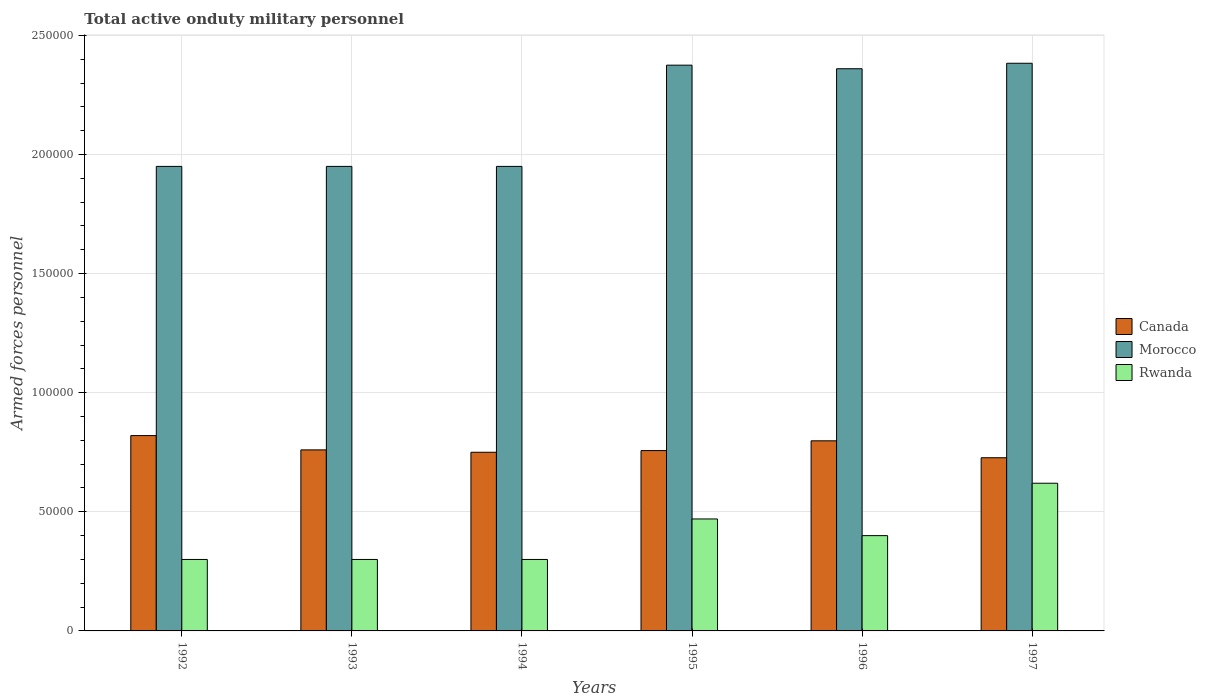How many different coloured bars are there?
Your answer should be very brief. 3. Are the number of bars on each tick of the X-axis equal?
Provide a succinct answer. Yes. How many bars are there on the 4th tick from the left?
Your answer should be compact. 3. In how many cases, is the number of bars for a given year not equal to the number of legend labels?
Keep it short and to the point. 0. What is the number of armed forces personnel in Morocco in 1996?
Your answer should be compact. 2.36e+05. Across all years, what is the maximum number of armed forces personnel in Morocco?
Give a very brief answer. 2.38e+05. Across all years, what is the minimum number of armed forces personnel in Rwanda?
Keep it short and to the point. 3.00e+04. What is the total number of armed forces personnel in Morocco in the graph?
Make the answer very short. 1.30e+06. What is the difference between the number of armed forces personnel in Rwanda in 1993 and that in 1996?
Your response must be concise. -10000. What is the difference between the number of armed forces personnel in Canada in 1997 and the number of armed forces personnel in Rwanda in 1995?
Offer a very short reply. 2.57e+04. What is the average number of armed forces personnel in Canada per year?
Your answer should be compact. 7.69e+04. In the year 1996, what is the difference between the number of armed forces personnel in Rwanda and number of armed forces personnel in Morocco?
Your answer should be very brief. -1.96e+05. What is the ratio of the number of armed forces personnel in Canada in 1993 to that in 1996?
Give a very brief answer. 0.95. Is the number of armed forces personnel in Morocco in 1995 less than that in 1997?
Provide a succinct answer. Yes. What is the difference between the highest and the second highest number of armed forces personnel in Morocco?
Give a very brief answer. 800. What is the difference between the highest and the lowest number of armed forces personnel in Canada?
Give a very brief answer. 9300. In how many years, is the number of armed forces personnel in Canada greater than the average number of armed forces personnel in Canada taken over all years?
Offer a very short reply. 2. Is the sum of the number of armed forces personnel in Canada in 1993 and 1996 greater than the maximum number of armed forces personnel in Rwanda across all years?
Your response must be concise. Yes. What does the 2nd bar from the left in 1996 represents?
Offer a very short reply. Morocco. What does the 1st bar from the right in 1994 represents?
Make the answer very short. Rwanda. Is it the case that in every year, the sum of the number of armed forces personnel in Rwanda and number of armed forces personnel in Canada is greater than the number of armed forces personnel in Morocco?
Keep it short and to the point. No. How many bars are there?
Ensure brevity in your answer.  18. Are all the bars in the graph horizontal?
Provide a short and direct response. No. How many years are there in the graph?
Give a very brief answer. 6. What is the difference between two consecutive major ticks on the Y-axis?
Offer a terse response. 5.00e+04. Does the graph contain grids?
Your answer should be compact. Yes. How many legend labels are there?
Provide a succinct answer. 3. What is the title of the graph?
Your answer should be compact. Total active onduty military personnel. Does "Ireland" appear as one of the legend labels in the graph?
Ensure brevity in your answer.  No. What is the label or title of the X-axis?
Your response must be concise. Years. What is the label or title of the Y-axis?
Provide a succinct answer. Armed forces personnel. What is the Armed forces personnel of Canada in 1992?
Your answer should be compact. 8.20e+04. What is the Armed forces personnel in Morocco in 1992?
Make the answer very short. 1.95e+05. What is the Armed forces personnel of Rwanda in 1992?
Provide a short and direct response. 3.00e+04. What is the Armed forces personnel in Canada in 1993?
Provide a succinct answer. 7.60e+04. What is the Armed forces personnel in Morocco in 1993?
Offer a very short reply. 1.95e+05. What is the Armed forces personnel in Rwanda in 1993?
Ensure brevity in your answer.  3.00e+04. What is the Armed forces personnel of Canada in 1994?
Offer a very short reply. 7.50e+04. What is the Armed forces personnel of Morocco in 1994?
Provide a succinct answer. 1.95e+05. What is the Armed forces personnel in Canada in 1995?
Give a very brief answer. 7.57e+04. What is the Armed forces personnel in Morocco in 1995?
Provide a short and direct response. 2.38e+05. What is the Armed forces personnel in Rwanda in 1995?
Make the answer very short. 4.70e+04. What is the Armed forces personnel in Canada in 1996?
Your response must be concise. 7.98e+04. What is the Armed forces personnel of Morocco in 1996?
Give a very brief answer. 2.36e+05. What is the Armed forces personnel in Canada in 1997?
Provide a short and direct response. 7.27e+04. What is the Armed forces personnel of Morocco in 1997?
Your answer should be compact. 2.38e+05. What is the Armed forces personnel in Rwanda in 1997?
Make the answer very short. 6.20e+04. Across all years, what is the maximum Armed forces personnel in Canada?
Your answer should be compact. 8.20e+04. Across all years, what is the maximum Armed forces personnel in Morocco?
Make the answer very short. 2.38e+05. Across all years, what is the maximum Armed forces personnel of Rwanda?
Ensure brevity in your answer.  6.20e+04. Across all years, what is the minimum Armed forces personnel in Canada?
Offer a very short reply. 7.27e+04. Across all years, what is the minimum Armed forces personnel in Morocco?
Keep it short and to the point. 1.95e+05. What is the total Armed forces personnel of Canada in the graph?
Give a very brief answer. 4.61e+05. What is the total Armed forces personnel of Morocco in the graph?
Your answer should be very brief. 1.30e+06. What is the total Armed forces personnel in Rwanda in the graph?
Your answer should be very brief. 2.39e+05. What is the difference between the Armed forces personnel in Canada in 1992 and that in 1993?
Your answer should be compact. 6000. What is the difference between the Armed forces personnel of Morocco in 1992 and that in 1993?
Make the answer very short. 0. What is the difference between the Armed forces personnel of Canada in 1992 and that in 1994?
Your answer should be very brief. 7000. What is the difference between the Armed forces personnel of Canada in 1992 and that in 1995?
Make the answer very short. 6300. What is the difference between the Armed forces personnel in Morocco in 1992 and that in 1995?
Make the answer very short. -4.25e+04. What is the difference between the Armed forces personnel of Rwanda in 1992 and that in 1995?
Your answer should be compact. -1.70e+04. What is the difference between the Armed forces personnel of Canada in 1992 and that in 1996?
Offer a terse response. 2200. What is the difference between the Armed forces personnel in Morocco in 1992 and that in 1996?
Offer a very short reply. -4.10e+04. What is the difference between the Armed forces personnel in Rwanda in 1992 and that in 1996?
Offer a very short reply. -10000. What is the difference between the Armed forces personnel of Canada in 1992 and that in 1997?
Offer a terse response. 9300. What is the difference between the Armed forces personnel of Morocco in 1992 and that in 1997?
Your response must be concise. -4.33e+04. What is the difference between the Armed forces personnel of Rwanda in 1992 and that in 1997?
Provide a succinct answer. -3.20e+04. What is the difference between the Armed forces personnel of Canada in 1993 and that in 1994?
Your response must be concise. 1000. What is the difference between the Armed forces personnel of Morocco in 1993 and that in 1994?
Provide a succinct answer. 0. What is the difference between the Armed forces personnel in Canada in 1993 and that in 1995?
Offer a terse response. 300. What is the difference between the Armed forces personnel of Morocco in 1993 and that in 1995?
Offer a terse response. -4.25e+04. What is the difference between the Armed forces personnel in Rwanda in 1993 and that in 1995?
Offer a terse response. -1.70e+04. What is the difference between the Armed forces personnel in Canada in 1993 and that in 1996?
Keep it short and to the point. -3800. What is the difference between the Armed forces personnel in Morocco in 1993 and that in 1996?
Offer a very short reply. -4.10e+04. What is the difference between the Armed forces personnel in Rwanda in 1993 and that in 1996?
Make the answer very short. -10000. What is the difference between the Armed forces personnel in Canada in 1993 and that in 1997?
Make the answer very short. 3300. What is the difference between the Armed forces personnel of Morocco in 1993 and that in 1997?
Make the answer very short. -4.33e+04. What is the difference between the Armed forces personnel in Rwanda in 1993 and that in 1997?
Your answer should be very brief. -3.20e+04. What is the difference between the Armed forces personnel in Canada in 1994 and that in 1995?
Ensure brevity in your answer.  -700. What is the difference between the Armed forces personnel of Morocco in 1994 and that in 1995?
Give a very brief answer. -4.25e+04. What is the difference between the Armed forces personnel in Rwanda in 1994 and that in 1995?
Offer a very short reply. -1.70e+04. What is the difference between the Armed forces personnel in Canada in 1994 and that in 1996?
Make the answer very short. -4800. What is the difference between the Armed forces personnel of Morocco in 1994 and that in 1996?
Provide a short and direct response. -4.10e+04. What is the difference between the Armed forces personnel in Canada in 1994 and that in 1997?
Your answer should be compact. 2300. What is the difference between the Armed forces personnel in Morocco in 1994 and that in 1997?
Offer a very short reply. -4.33e+04. What is the difference between the Armed forces personnel of Rwanda in 1994 and that in 1997?
Your answer should be very brief. -3.20e+04. What is the difference between the Armed forces personnel in Canada in 1995 and that in 1996?
Give a very brief answer. -4100. What is the difference between the Armed forces personnel of Morocco in 1995 and that in 1996?
Your answer should be very brief. 1500. What is the difference between the Armed forces personnel of Rwanda in 1995 and that in 1996?
Provide a succinct answer. 7000. What is the difference between the Armed forces personnel in Canada in 1995 and that in 1997?
Offer a terse response. 3000. What is the difference between the Armed forces personnel in Morocco in 1995 and that in 1997?
Offer a very short reply. -800. What is the difference between the Armed forces personnel of Rwanda in 1995 and that in 1997?
Your answer should be very brief. -1.50e+04. What is the difference between the Armed forces personnel in Canada in 1996 and that in 1997?
Make the answer very short. 7100. What is the difference between the Armed forces personnel of Morocco in 1996 and that in 1997?
Provide a succinct answer. -2300. What is the difference between the Armed forces personnel in Rwanda in 1996 and that in 1997?
Provide a succinct answer. -2.20e+04. What is the difference between the Armed forces personnel of Canada in 1992 and the Armed forces personnel of Morocco in 1993?
Make the answer very short. -1.13e+05. What is the difference between the Armed forces personnel of Canada in 1992 and the Armed forces personnel of Rwanda in 1993?
Your answer should be very brief. 5.20e+04. What is the difference between the Armed forces personnel of Morocco in 1992 and the Armed forces personnel of Rwanda in 1993?
Give a very brief answer. 1.65e+05. What is the difference between the Armed forces personnel of Canada in 1992 and the Armed forces personnel of Morocco in 1994?
Offer a terse response. -1.13e+05. What is the difference between the Armed forces personnel in Canada in 1992 and the Armed forces personnel in Rwanda in 1994?
Provide a short and direct response. 5.20e+04. What is the difference between the Armed forces personnel of Morocco in 1992 and the Armed forces personnel of Rwanda in 1994?
Your answer should be very brief. 1.65e+05. What is the difference between the Armed forces personnel in Canada in 1992 and the Armed forces personnel in Morocco in 1995?
Provide a short and direct response. -1.56e+05. What is the difference between the Armed forces personnel of Canada in 1992 and the Armed forces personnel of Rwanda in 1995?
Offer a very short reply. 3.50e+04. What is the difference between the Armed forces personnel in Morocco in 1992 and the Armed forces personnel in Rwanda in 1995?
Your response must be concise. 1.48e+05. What is the difference between the Armed forces personnel of Canada in 1992 and the Armed forces personnel of Morocco in 1996?
Your answer should be compact. -1.54e+05. What is the difference between the Armed forces personnel in Canada in 1992 and the Armed forces personnel in Rwanda in 1996?
Provide a succinct answer. 4.20e+04. What is the difference between the Armed forces personnel in Morocco in 1992 and the Armed forces personnel in Rwanda in 1996?
Offer a terse response. 1.55e+05. What is the difference between the Armed forces personnel of Canada in 1992 and the Armed forces personnel of Morocco in 1997?
Your answer should be very brief. -1.56e+05. What is the difference between the Armed forces personnel in Morocco in 1992 and the Armed forces personnel in Rwanda in 1997?
Your answer should be very brief. 1.33e+05. What is the difference between the Armed forces personnel in Canada in 1993 and the Armed forces personnel in Morocco in 1994?
Your response must be concise. -1.19e+05. What is the difference between the Armed forces personnel of Canada in 1993 and the Armed forces personnel of Rwanda in 1994?
Your response must be concise. 4.60e+04. What is the difference between the Armed forces personnel in Morocco in 1993 and the Armed forces personnel in Rwanda in 1994?
Keep it short and to the point. 1.65e+05. What is the difference between the Armed forces personnel of Canada in 1993 and the Armed forces personnel of Morocco in 1995?
Your answer should be compact. -1.62e+05. What is the difference between the Armed forces personnel of Canada in 1993 and the Armed forces personnel of Rwanda in 1995?
Your answer should be compact. 2.90e+04. What is the difference between the Armed forces personnel in Morocco in 1993 and the Armed forces personnel in Rwanda in 1995?
Provide a succinct answer. 1.48e+05. What is the difference between the Armed forces personnel of Canada in 1993 and the Armed forces personnel of Morocco in 1996?
Keep it short and to the point. -1.60e+05. What is the difference between the Armed forces personnel of Canada in 1993 and the Armed forces personnel of Rwanda in 1996?
Keep it short and to the point. 3.60e+04. What is the difference between the Armed forces personnel of Morocco in 1993 and the Armed forces personnel of Rwanda in 1996?
Your answer should be compact. 1.55e+05. What is the difference between the Armed forces personnel in Canada in 1993 and the Armed forces personnel in Morocco in 1997?
Your response must be concise. -1.62e+05. What is the difference between the Armed forces personnel in Canada in 1993 and the Armed forces personnel in Rwanda in 1997?
Your answer should be very brief. 1.40e+04. What is the difference between the Armed forces personnel in Morocco in 1993 and the Armed forces personnel in Rwanda in 1997?
Keep it short and to the point. 1.33e+05. What is the difference between the Armed forces personnel of Canada in 1994 and the Armed forces personnel of Morocco in 1995?
Make the answer very short. -1.62e+05. What is the difference between the Armed forces personnel of Canada in 1994 and the Armed forces personnel of Rwanda in 1995?
Your answer should be very brief. 2.80e+04. What is the difference between the Armed forces personnel in Morocco in 1994 and the Armed forces personnel in Rwanda in 1995?
Ensure brevity in your answer.  1.48e+05. What is the difference between the Armed forces personnel in Canada in 1994 and the Armed forces personnel in Morocco in 1996?
Your answer should be very brief. -1.61e+05. What is the difference between the Armed forces personnel of Canada in 1994 and the Armed forces personnel of Rwanda in 1996?
Make the answer very short. 3.50e+04. What is the difference between the Armed forces personnel in Morocco in 1994 and the Armed forces personnel in Rwanda in 1996?
Provide a short and direct response. 1.55e+05. What is the difference between the Armed forces personnel of Canada in 1994 and the Armed forces personnel of Morocco in 1997?
Keep it short and to the point. -1.63e+05. What is the difference between the Armed forces personnel of Canada in 1994 and the Armed forces personnel of Rwanda in 1997?
Keep it short and to the point. 1.30e+04. What is the difference between the Armed forces personnel of Morocco in 1994 and the Armed forces personnel of Rwanda in 1997?
Provide a succinct answer. 1.33e+05. What is the difference between the Armed forces personnel of Canada in 1995 and the Armed forces personnel of Morocco in 1996?
Ensure brevity in your answer.  -1.60e+05. What is the difference between the Armed forces personnel in Canada in 1995 and the Armed forces personnel in Rwanda in 1996?
Provide a succinct answer. 3.57e+04. What is the difference between the Armed forces personnel in Morocco in 1995 and the Armed forces personnel in Rwanda in 1996?
Provide a short and direct response. 1.98e+05. What is the difference between the Armed forces personnel in Canada in 1995 and the Armed forces personnel in Morocco in 1997?
Offer a very short reply. -1.63e+05. What is the difference between the Armed forces personnel in Canada in 1995 and the Armed forces personnel in Rwanda in 1997?
Provide a succinct answer. 1.37e+04. What is the difference between the Armed forces personnel of Morocco in 1995 and the Armed forces personnel of Rwanda in 1997?
Provide a succinct answer. 1.76e+05. What is the difference between the Armed forces personnel in Canada in 1996 and the Armed forces personnel in Morocco in 1997?
Offer a very short reply. -1.58e+05. What is the difference between the Armed forces personnel of Canada in 1996 and the Armed forces personnel of Rwanda in 1997?
Your response must be concise. 1.78e+04. What is the difference between the Armed forces personnel in Morocco in 1996 and the Armed forces personnel in Rwanda in 1997?
Ensure brevity in your answer.  1.74e+05. What is the average Armed forces personnel of Canada per year?
Offer a terse response. 7.69e+04. What is the average Armed forces personnel of Morocco per year?
Ensure brevity in your answer.  2.16e+05. What is the average Armed forces personnel in Rwanda per year?
Your response must be concise. 3.98e+04. In the year 1992, what is the difference between the Armed forces personnel of Canada and Armed forces personnel of Morocco?
Make the answer very short. -1.13e+05. In the year 1992, what is the difference between the Armed forces personnel of Canada and Armed forces personnel of Rwanda?
Your response must be concise. 5.20e+04. In the year 1992, what is the difference between the Armed forces personnel in Morocco and Armed forces personnel in Rwanda?
Your answer should be very brief. 1.65e+05. In the year 1993, what is the difference between the Armed forces personnel in Canada and Armed forces personnel in Morocco?
Keep it short and to the point. -1.19e+05. In the year 1993, what is the difference between the Armed forces personnel in Canada and Armed forces personnel in Rwanda?
Provide a succinct answer. 4.60e+04. In the year 1993, what is the difference between the Armed forces personnel of Morocco and Armed forces personnel of Rwanda?
Offer a very short reply. 1.65e+05. In the year 1994, what is the difference between the Armed forces personnel in Canada and Armed forces personnel in Rwanda?
Provide a succinct answer. 4.50e+04. In the year 1994, what is the difference between the Armed forces personnel of Morocco and Armed forces personnel of Rwanda?
Your answer should be compact. 1.65e+05. In the year 1995, what is the difference between the Armed forces personnel of Canada and Armed forces personnel of Morocco?
Keep it short and to the point. -1.62e+05. In the year 1995, what is the difference between the Armed forces personnel in Canada and Armed forces personnel in Rwanda?
Your answer should be very brief. 2.87e+04. In the year 1995, what is the difference between the Armed forces personnel of Morocco and Armed forces personnel of Rwanda?
Keep it short and to the point. 1.90e+05. In the year 1996, what is the difference between the Armed forces personnel of Canada and Armed forces personnel of Morocco?
Your answer should be very brief. -1.56e+05. In the year 1996, what is the difference between the Armed forces personnel in Canada and Armed forces personnel in Rwanda?
Provide a short and direct response. 3.98e+04. In the year 1996, what is the difference between the Armed forces personnel in Morocco and Armed forces personnel in Rwanda?
Provide a short and direct response. 1.96e+05. In the year 1997, what is the difference between the Armed forces personnel of Canada and Armed forces personnel of Morocco?
Your answer should be compact. -1.66e+05. In the year 1997, what is the difference between the Armed forces personnel of Canada and Armed forces personnel of Rwanda?
Offer a terse response. 1.07e+04. In the year 1997, what is the difference between the Armed forces personnel of Morocco and Armed forces personnel of Rwanda?
Your answer should be compact. 1.76e+05. What is the ratio of the Armed forces personnel of Canada in 1992 to that in 1993?
Offer a terse response. 1.08. What is the ratio of the Armed forces personnel in Morocco in 1992 to that in 1993?
Ensure brevity in your answer.  1. What is the ratio of the Armed forces personnel in Rwanda in 1992 to that in 1993?
Provide a short and direct response. 1. What is the ratio of the Armed forces personnel of Canada in 1992 to that in 1994?
Ensure brevity in your answer.  1.09. What is the ratio of the Armed forces personnel of Canada in 1992 to that in 1995?
Ensure brevity in your answer.  1.08. What is the ratio of the Armed forces personnel of Morocco in 1992 to that in 1995?
Offer a very short reply. 0.82. What is the ratio of the Armed forces personnel in Rwanda in 1992 to that in 1995?
Ensure brevity in your answer.  0.64. What is the ratio of the Armed forces personnel of Canada in 1992 to that in 1996?
Ensure brevity in your answer.  1.03. What is the ratio of the Armed forces personnel of Morocco in 1992 to that in 1996?
Make the answer very short. 0.83. What is the ratio of the Armed forces personnel of Rwanda in 1992 to that in 1996?
Ensure brevity in your answer.  0.75. What is the ratio of the Armed forces personnel in Canada in 1992 to that in 1997?
Your response must be concise. 1.13. What is the ratio of the Armed forces personnel in Morocco in 1992 to that in 1997?
Provide a short and direct response. 0.82. What is the ratio of the Armed forces personnel of Rwanda in 1992 to that in 1997?
Offer a very short reply. 0.48. What is the ratio of the Armed forces personnel in Canada in 1993 to that in 1994?
Provide a short and direct response. 1.01. What is the ratio of the Armed forces personnel of Morocco in 1993 to that in 1994?
Provide a short and direct response. 1. What is the ratio of the Armed forces personnel of Morocco in 1993 to that in 1995?
Make the answer very short. 0.82. What is the ratio of the Armed forces personnel of Rwanda in 1993 to that in 1995?
Your answer should be compact. 0.64. What is the ratio of the Armed forces personnel in Morocco in 1993 to that in 1996?
Give a very brief answer. 0.83. What is the ratio of the Armed forces personnel of Rwanda in 1993 to that in 1996?
Ensure brevity in your answer.  0.75. What is the ratio of the Armed forces personnel in Canada in 1993 to that in 1997?
Give a very brief answer. 1.05. What is the ratio of the Armed forces personnel in Morocco in 1993 to that in 1997?
Provide a succinct answer. 0.82. What is the ratio of the Armed forces personnel in Rwanda in 1993 to that in 1997?
Offer a very short reply. 0.48. What is the ratio of the Armed forces personnel of Canada in 1994 to that in 1995?
Your response must be concise. 0.99. What is the ratio of the Armed forces personnel in Morocco in 1994 to that in 1995?
Keep it short and to the point. 0.82. What is the ratio of the Armed forces personnel of Rwanda in 1994 to that in 1995?
Offer a terse response. 0.64. What is the ratio of the Armed forces personnel of Canada in 1994 to that in 1996?
Keep it short and to the point. 0.94. What is the ratio of the Armed forces personnel in Morocco in 1994 to that in 1996?
Your answer should be very brief. 0.83. What is the ratio of the Armed forces personnel in Canada in 1994 to that in 1997?
Offer a terse response. 1.03. What is the ratio of the Armed forces personnel in Morocco in 1994 to that in 1997?
Make the answer very short. 0.82. What is the ratio of the Armed forces personnel of Rwanda in 1994 to that in 1997?
Make the answer very short. 0.48. What is the ratio of the Armed forces personnel of Canada in 1995 to that in 1996?
Your answer should be very brief. 0.95. What is the ratio of the Armed forces personnel of Morocco in 1995 to that in 1996?
Keep it short and to the point. 1.01. What is the ratio of the Armed forces personnel of Rwanda in 1995 to that in 1996?
Offer a very short reply. 1.18. What is the ratio of the Armed forces personnel in Canada in 1995 to that in 1997?
Offer a terse response. 1.04. What is the ratio of the Armed forces personnel in Morocco in 1995 to that in 1997?
Your answer should be very brief. 1. What is the ratio of the Armed forces personnel in Rwanda in 1995 to that in 1997?
Your response must be concise. 0.76. What is the ratio of the Armed forces personnel in Canada in 1996 to that in 1997?
Offer a very short reply. 1.1. What is the ratio of the Armed forces personnel in Morocco in 1996 to that in 1997?
Keep it short and to the point. 0.99. What is the ratio of the Armed forces personnel of Rwanda in 1996 to that in 1997?
Provide a short and direct response. 0.65. What is the difference between the highest and the second highest Armed forces personnel of Canada?
Provide a succinct answer. 2200. What is the difference between the highest and the second highest Armed forces personnel of Morocco?
Provide a succinct answer. 800. What is the difference between the highest and the second highest Armed forces personnel of Rwanda?
Provide a short and direct response. 1.50e+04. What is the difference between the highest and the lowest Armed forces personnel in Canada?
Offer a terse response. 9300. What is the difference between the highest and the lowest Armed forces personnel of Morocco?
Offer a terse response. 4.33e+04. What is the difference between the highest and the lowest Armed forces personnel in Rwanda?
Ensure brevity in your answer.  3.20e+04. 